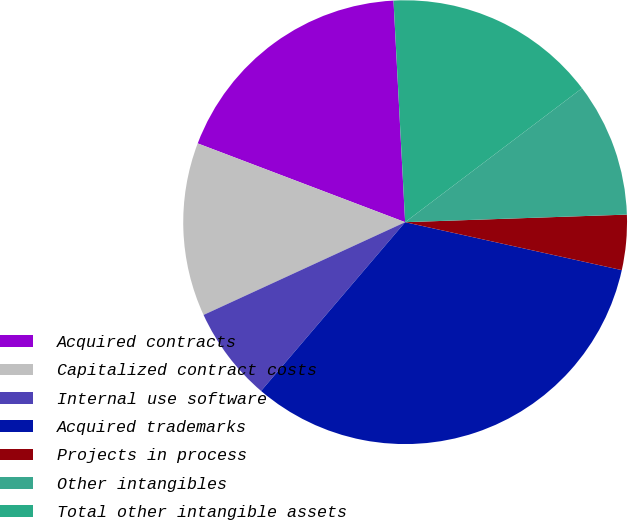Convert chart to OTSL. <chart><loc_0><loc_0><loc_500><loc_500><pie_chart><fcel>Acquired contracts<fcel>Capitalized contract costs<fcel>Internal use software<fcel>Acquired trademarks<fcel>Projects in process<fcel>Other intangibles<fcel>Total other intangible assets<nl><fcel>18.39%<fcel>12.64%<fcel>6.89%<fcel>32.78%<fcel>4.01%<fcel>9.77%<fcel>15.52%<nl></chart> 